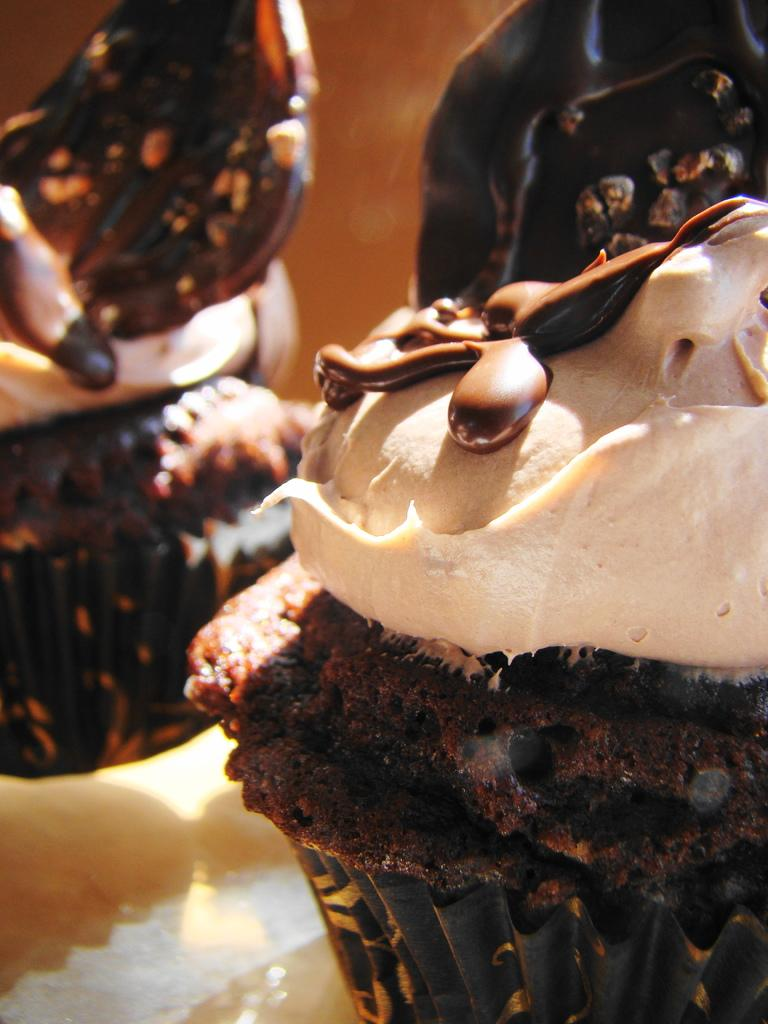How many ice creams are visible in the image? There are two ice creams in the image. Where are the ice creams located? The ice creams are in a plate. What colors of cream are present in the image? There is chocolate and white color creams in the image. Can you tell me the weight of the owl sitting on the scale in the image? There is no owl or scale present in the image; it only features two ice creams in a plate with chocolate and white color creams. 